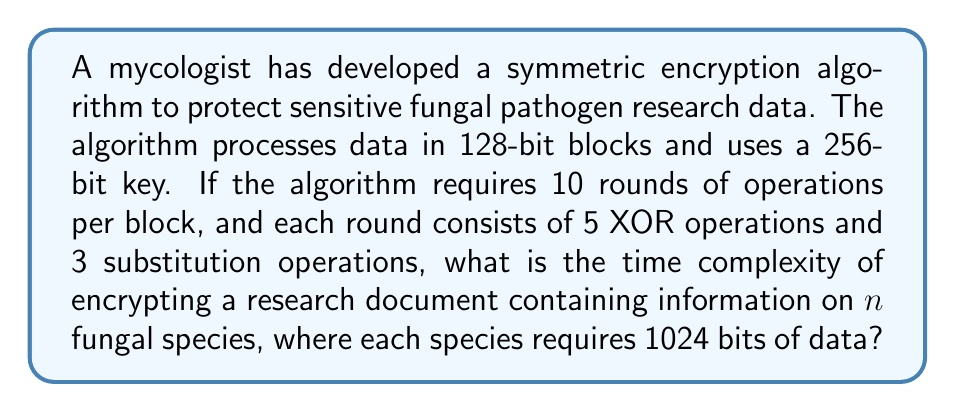Teach me how to tackle this problem. Let's break this down step-by-step:

1) First, we need to calculate the number of blocks required to encrypt the entire document:
   - Each species requires 1024 bits of data
   - Total bits in the document = $1024n$
   - Number of 128-bit blocks = $\frac{1024n}{128} = 8n$

2) For each block, the algorithm performs 10 rounds of operations:
   - Each round has 5 XOR operations and 3 substitution operations
   - Total operations per round = $5 + 3 = 8$
   - Total operations per block = $8 \times 10 = 80$

3) The total number of operations for the entire document:
   - Number of operations = Number of blocks × Operations per block
   - $\text{Total operations} = 8n \times 80 = 640n$

4) In big O notation, we ignore constant factors. Therefore, the time complexity is $O(n)$.

This means the time complexity of the encryption algorithm grows linearly with the number of fungal species in the research document.
Answer: $O(n)$ 